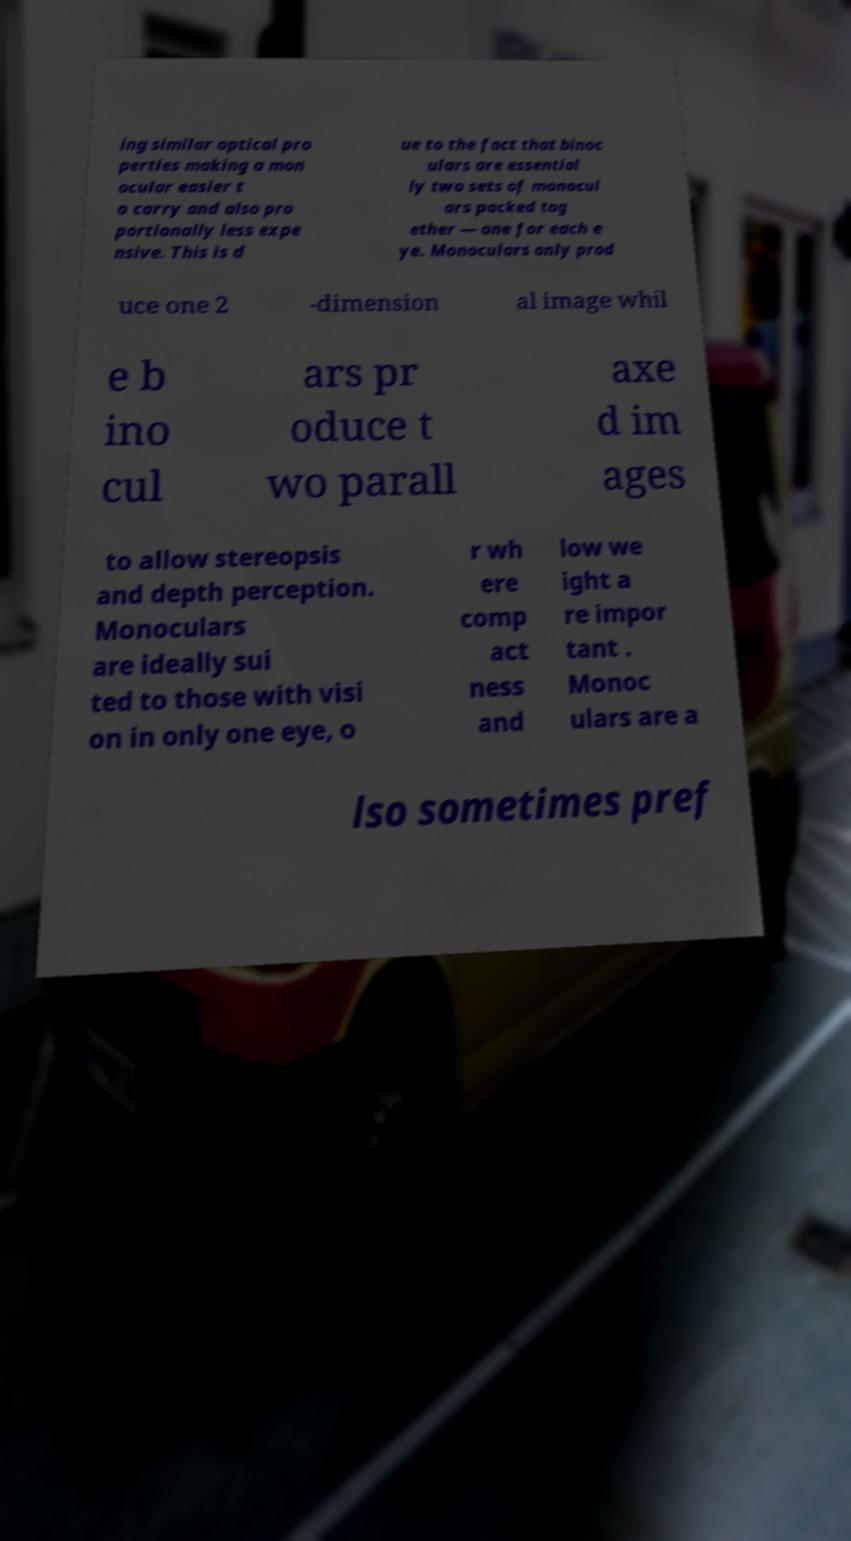What messages or text are displayed in this image? I need them in a readable, typed format. ing similar optical pro perties making a mon ocular easier t o carry and also pro portionally less expe nsive. This is d ue to the fact that binoc ulars are essential ly two sets of monocul ars packed tog ether — one for each e ye. Monoculars only prod uce one 2 -dimension al image whil e b ino cul ars pr oduce t wo parall axe d im ages to allow stereopsis and depth perception. Monoculars are ideally sui ted to those with visi on in only one eye, o r wh ere comp act ness and low we ight a re impor tant . Monoc ulars are a lso sometimes pref 